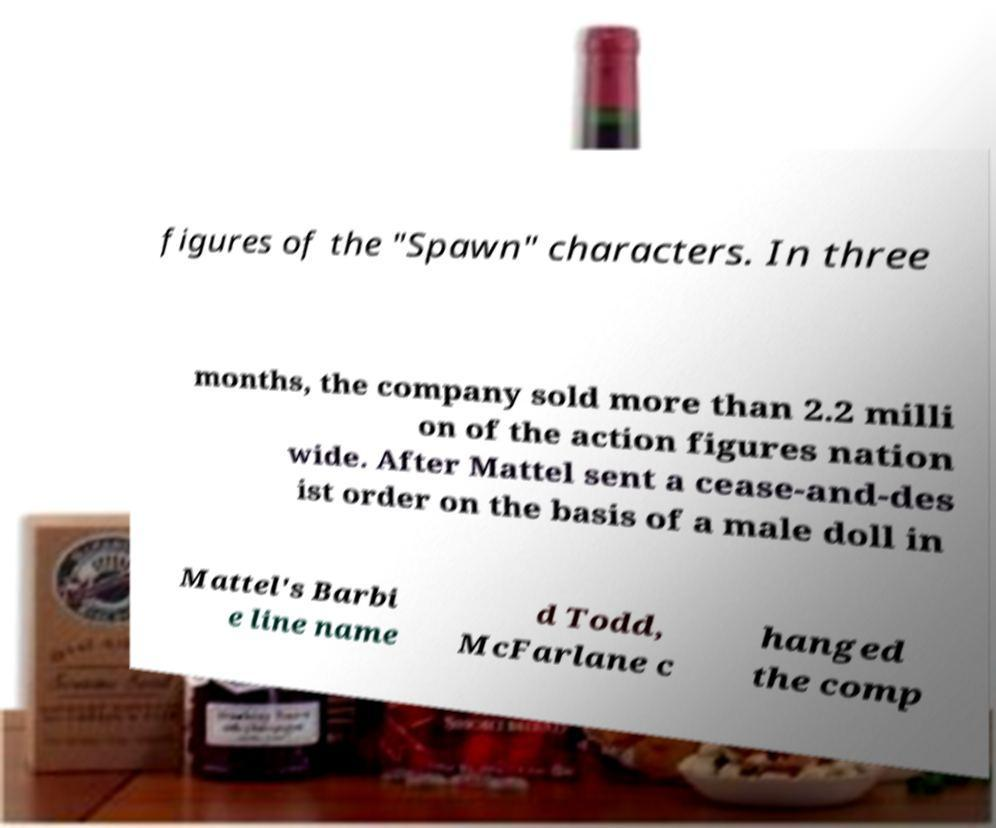Can you read and provide the text displayed in the image?This photo seems to have some interesting text. Can you extract and type it out for me? figures of the "Spawn" characters. In three months, the company sold more than 2.2 milli on of the action figures nation wide. After Mattel sent a cease-and-des ist order on the basis of a male doll in Mattel's Barbi e line name d Todd, McFarlane c hanged the comp 